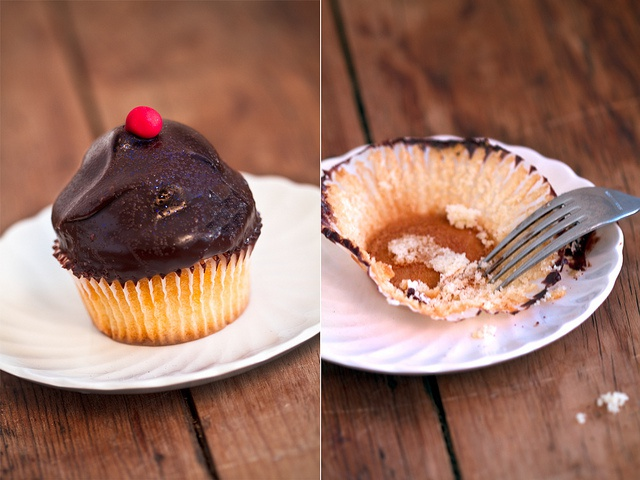Describe the objects in this image and their specific colors. I can see dining table in brown, maroon, and black tones, dining table in brown, maroon, and black tones, cake in brown, maroon, black, and orange tones, and fork in brown and gray tones in this image. 